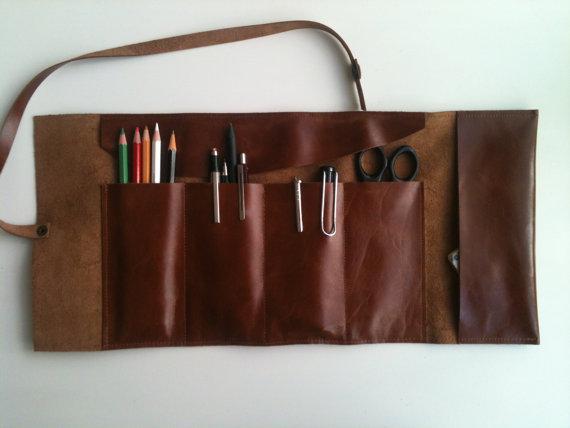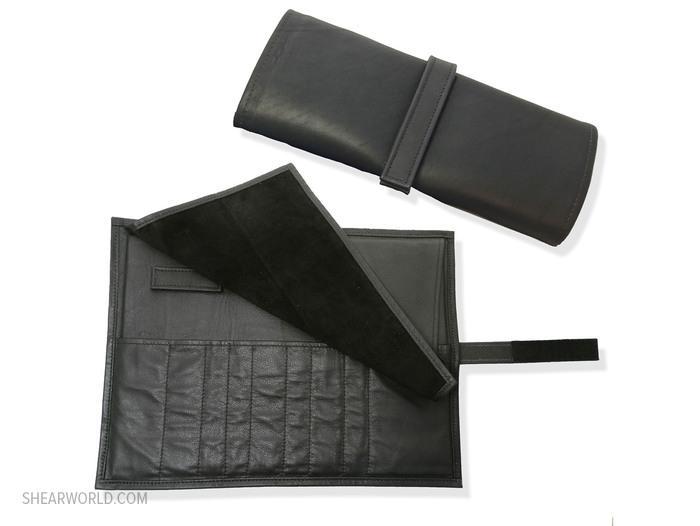The first image is the image on the left, the second image is the image on the right. Considering the images on both sides, is "The left image shows one filled brown leather pencil case opened and right-side up, and the right image contains no more than two pencil cases." valid? Answer yes or no. Yes. 